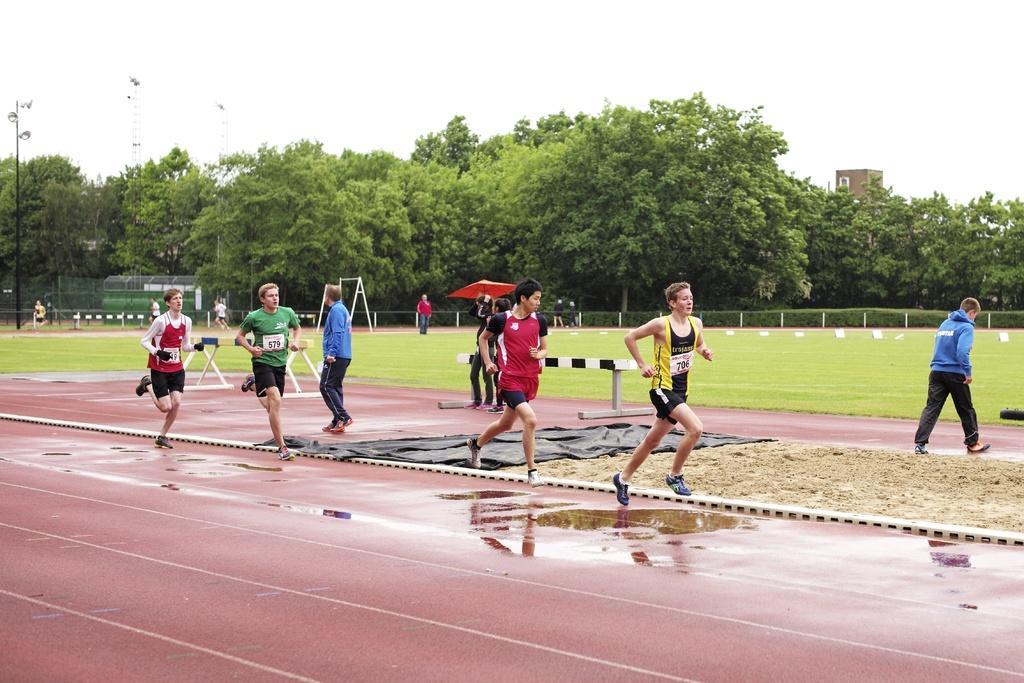How would you summarize this image in a sentence or two? This picture I can see in the middle a man is running, he wore yellow and black color top and black color short. Behind him few other men are also running, at the bottom there is the water. At the back side there is the net and there are trees, at the top it is the sky. 